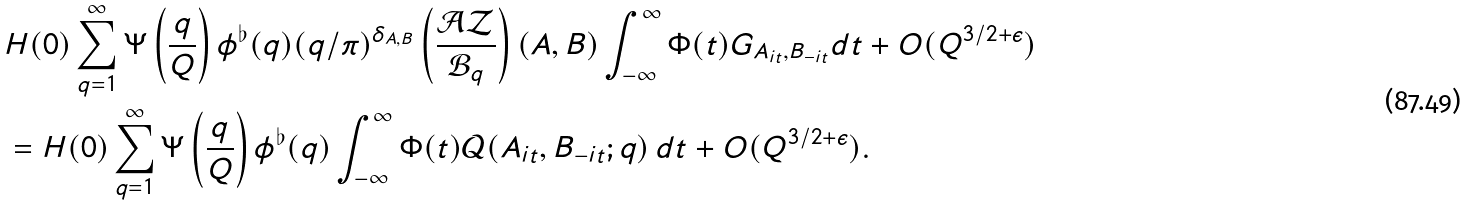Convert formula to latex. <formula><loc_0><loc_0><loc_500><loc_500>& H ( 0 ) \sum _ { q = 1 } ^ { \infty } \Psi \left ( \frac { q } { Q } \right ) \phi ^ { \flat } ( q ) ( q / \pi ) ^ { \delta _ { A , B } } \left ( \frac { \mathcal { A Z } } { \mathcal { B } _ { q } } \right ) ( A , B ) \int _ { - \infty } ^ { \infty } \Phi ( t ) G _ { A _ { i t } , B _ { - i t } } d t + O ( Q ^ { 3 / 2 + \epsilon } ) \\ & = H ( 0 ) \sum _ { q = 1 } ^ { \infty } \Psi \left ( \frac { q } { Q } \right ) \phi ^ { \flat } ( q ) \int _ { - \infty } ^ { \infty } \Phi ( t ) \mathcal { Q } ( A _ { i t } , B _ { - i t } ; q ) \, d t + O ( Q ^ { 3 / 2 + \epsilon } ) .</formula> 